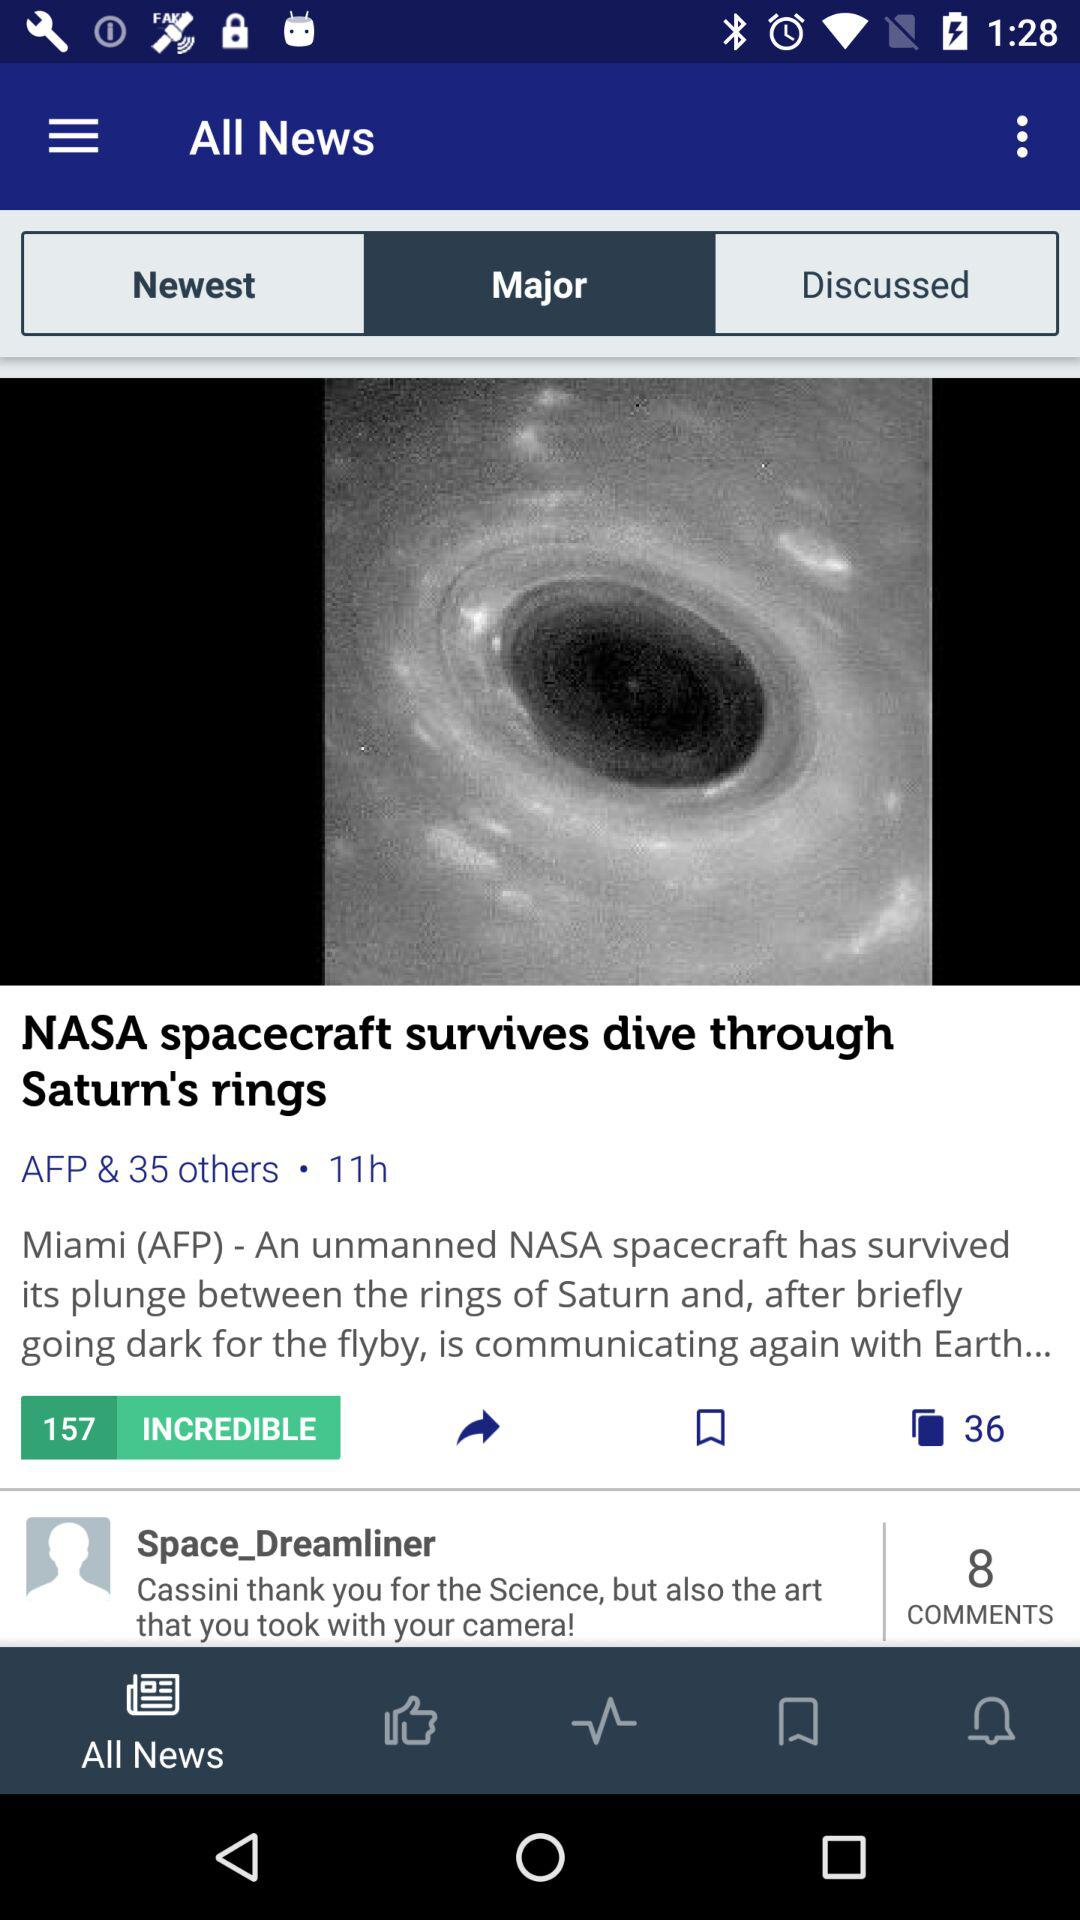Which tab is currently selected in "All News"? The currently selected tab is "Major". 